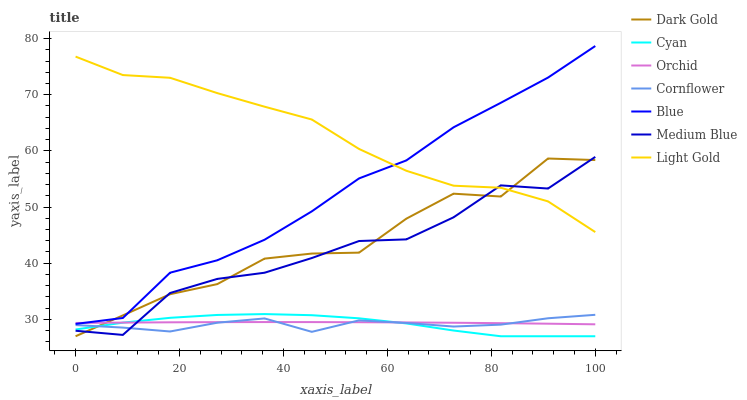Does Cornflower have the minimum area under the curve?
Answer yes or no. Yes. Does Light Gold have the maximum area under the curve?
Answer yes or no. Yes. Does Dark Gold have the minimum area under the curve?
Answer yes or no. No. Does Dark Gold have the maximum area under the curve?
Answer yes or no. No. Is Orchid the smoothest?
Answer yes or no. Yes. Is Medium Blue the roughest?
Answer yes or no. Yes. Is Cornflower the smoothest?
Answer yes or no. No. Is Cornflower the roughest?
Answer yes or no. No. Does Dark Gold have the lowest value?
Answer yes or no. Yes. Does Cornflower have the lowest value?
Answer yes or no. No. Does Blue have the highest value?
Answer yes or no. Yes. Does Cornflower have the highest value?
Answer yes or no. No. Is Cornflower less than Blue?
Answer yes or no. Yes. Is Blue greater than Medium Blue?
Answer yes or no. Yes. Does Medium Blue intersect Dark Gold?
Answer yes or no. Yes. Is Medium Blue less than Dark Gold?
Answer yes or no. No. Is Medium Blue greater than Dark Gold?
Answer yes or no. No. Does Cornflower intersect Blue?
Answer yes or no. No. 